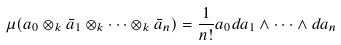Convert formula to latex. <formula><loc_0><loc_0><loc_500><loc_500>\mu ( a _ { 0 } \otimes _ { k } \bar { a } _ { 1 } \otimes _ { k } \dots \otimes _ { k } \bar { a } _ { n } ) = \frac { 1 } { n ! } a _ { 0 } d a _ { 1 } \land \dots \land d a _ { n }</formula> 